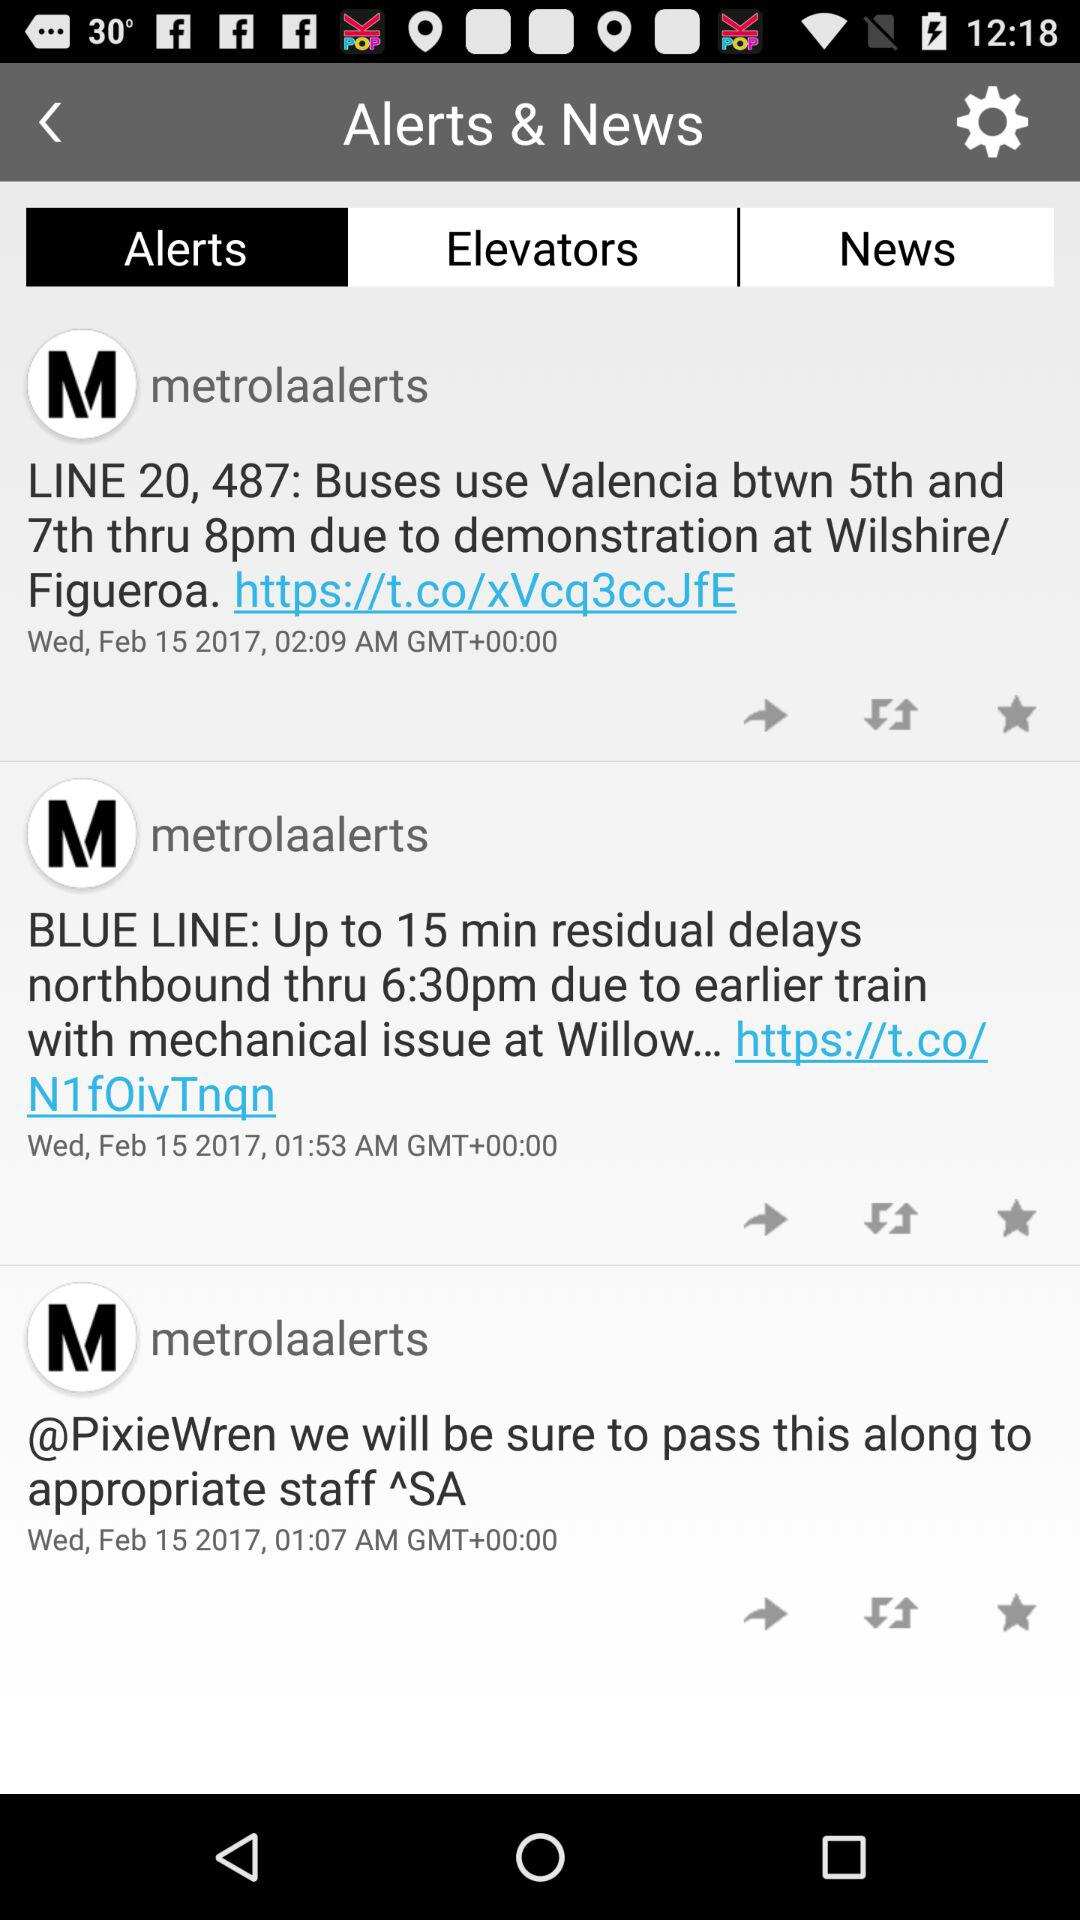How many alerts are there in total?
Answer the question using a single word or phrase. 3 